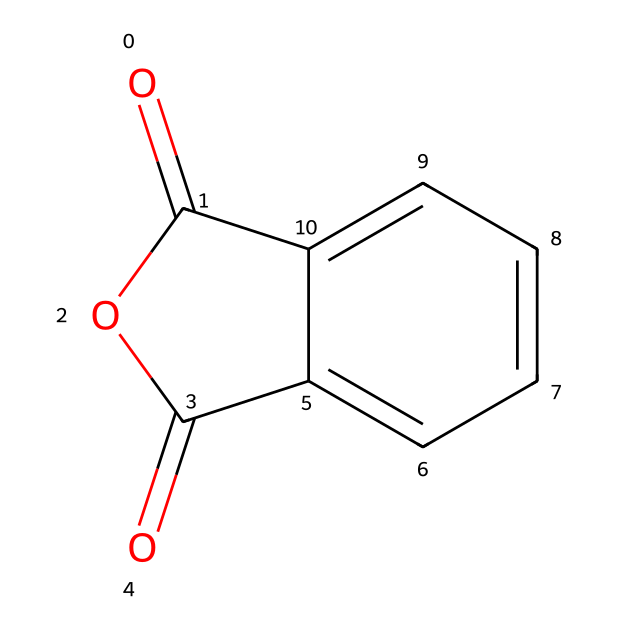What is the core structure of phthalic anhydride? The core structure consists of a cyclic anhydride formed from phthalic acid. The structure includes two carbonyl groups and a fused aromatic ring.
Answer: cyclic anhydride How many carbon atoms are present in phthalic anhydride? By analyzing the SMILES representation, we can count the carbon atoms. There are 8 carbon atoms in the structure of phthalic anhydride.
Answer: 8 What functional groups are present in phthalic anhydride? The presence of two carbonyl (C=O) groups and an ether linkage (O) in the structure represents the functional groups in phthalic anhydride.
Answer: carbonyl, ether What type of chemical is phthalic anhydride categorized as? Phthalic anhydride fits into the category of acid anhydrides because it is derived from the dehydration of phthalic acid.
Answer: acid anhydride How many oxygen atoms are present in phthalic anhydride? By examining the structure in the SMILES notation, we find two carbonyl oxygens and one ether oxygen, totaling three oxygen atoms.
Answer: 3 What is the implication of the fused ring structure in phthalic anhydride for its stability? The fused ring structure enhances the stability due to resonance stabilization in the aromatic system, contributing to the overall robustness of the molecule.
Answer: stability 